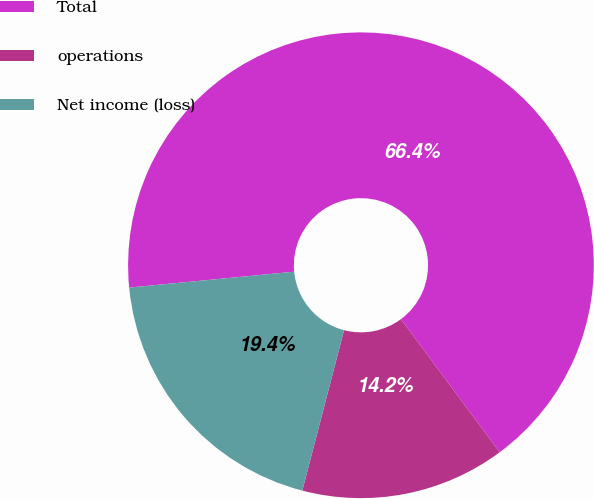Convert chart. <chart><loc_0><loc_0><loc_500><loc_500><pie_chart><fcel>Total<fcel>operations<fcel>Net income (loss)<nl><fcel>66.37%<fcel>14.21%<fcel>19.42%<nl></chart> 